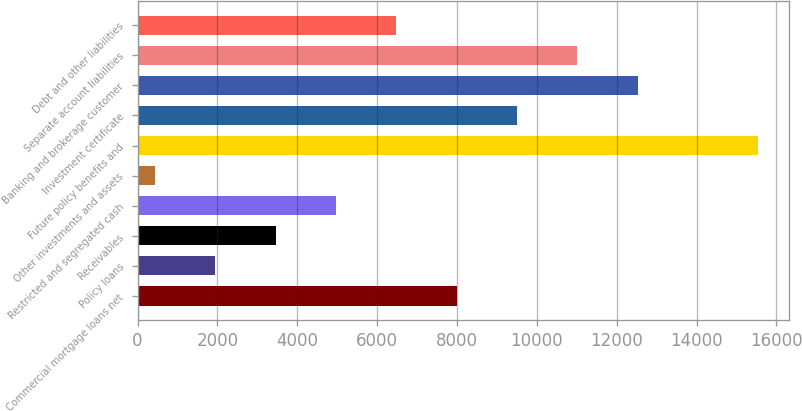Convert chart to OTSL. <chart><loc_0><loc_0><loc_500><loc_500><bar_chart><fcel>Commercial mortgage loans net<fcel>Policy loans<fcel>Receivables<fcel>Restricted and segregated cash<fcel>Other investments and assets<fcel>Future policy benefits and<fcel>Investment certificate<fcel>Banking and brokerage customer<fcel>Separate account liabilities<fcel>Debt and other liabilities<nl><fcel>7989.5<fcel>1949.1<fcel>3459.2<fcel>4969.3<fcel>439<fcel>15540<fcel>9499.6<fcel>12519.8<fcel>11009.7<fcel>6479.4<nl></chart> 